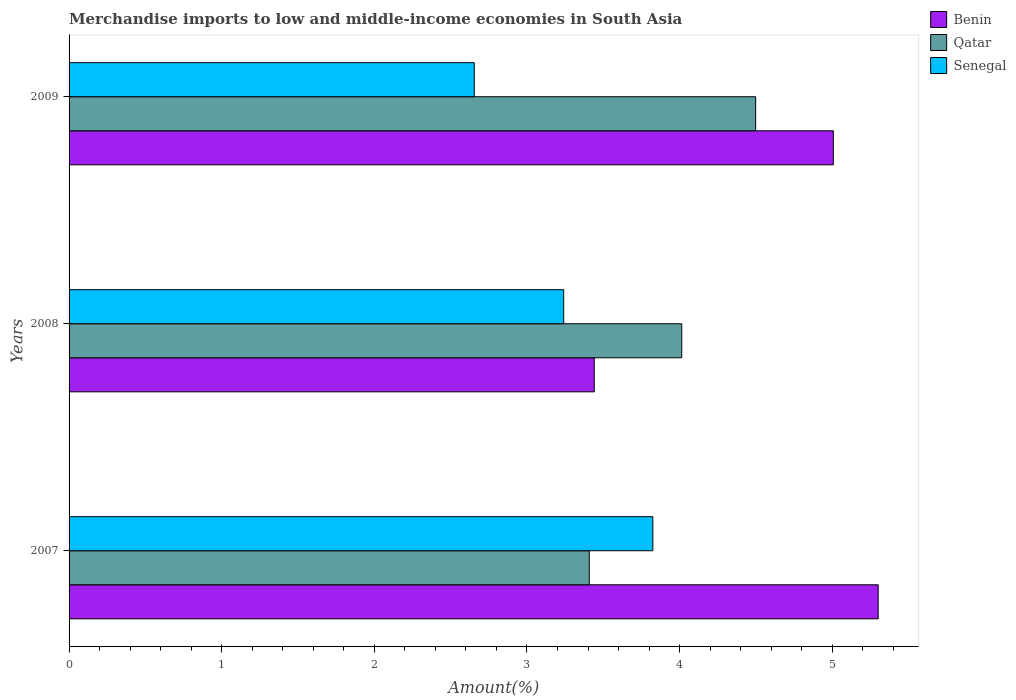Are the number of bars on each tick of the Y-axis equal?
Your answer should be very brief. Yes. How many bars are there on the 1st tick from the bottom?
Keep it short and to the point. 3. What is the label of the 2nd group of bars from the top?
Your response must be concise. 2008. What is the percentage of amount earned from merchandise imports in Senegal in 2007?
Keep it short and to the point. 3.82. Across all years, what is the maximum percentage of amount earned from merchandise imports in Qatar?
Your answer should be compact. 4.5. Across all years, what is the minimum percentage of amount earned from merchandise imports in Benin?
Make the answer very short. 3.44. In which year was the percentage of amount earned from merchandise imports in Benin maximum?
Give a very brief answer. 2007. In which year was the percentage of amount earned from merchandise imports in Benin minimum?
Your response must be concise. 2008. What is the total percentage of amount earned from merchandise imports in Qatar in the graph?
Provide a succinct answer. 11.92. What is the difference between the percentage of amount earned from merchandise imports in Senegal in 2007 and that in 2009?
Offer a terse response. 1.17. What is the difference between the percentage of amount earned from merchandise imports in Benin in 2009 and the percentage of amount earned from merchandise imports in Qatar in 2007?
Your answer should be very brief. 1.6. What is the average percentage of amount earned from merchandise imports in Qatar per year?
Keep it short and to the point. 3.97. In the year 2009, what is the difference between the percentage of amount earned from merchandise imports in Benin and percentage of amount earned from merchandise imports in Qatar?
Offer a very short reply. 0.51. What is the ratio of the percentage of amount earned from merchandise imports in Benin in 2007 to that in 2009?
Your response must be concise. 1.06. Is the difference between the percentage of amount earned from merchandise imports in Benin in 2007 and 2008 greater than the difference between the percentage of amount earned from merchandise imports in Qatar in 2007 and 2008?
Make the answer very short. Yes. What is the difference between the highest and the second highest percentage of amount earned from merchandise imports in Benin?
Provide a short and direct response. 0.29. What is the difference between the highest and the lowest percentage of amount earned from merchandise imports in Qatar?
Provide a succinct answer. 1.09. In how many years, is the percentage of amount earned from merchandise imports in Benin greater than the average percentage of amount earned from merchandise imports in Benin taken over all years?
Ensure brevity in your answer.  2. What does the 1st bar from the top in 2007 represents?
Your response must be concise. Senegal. What does the 3rd bar from the bottom in 2009 represents?
Make the answer very short. Senegal. How many years are there in the graph?
Provide a short and direct response. 3. Does the graph contain any zero values?
Your answer should be very brief. No. Where does the legend appear in the graph?
Your answer should be very brief. Top right. How many legend labels are there?
Make the answer very short. 3. How are the legend labels stacked?
Offer a terse response. Vertical. What is the title of the graph?
Ensure brevity in your answer.  Merchandise imports to low and middle-income economies in South Asia. What is the label or title of the X-axis?
Offer a terse response. Amount(%). What is the label or title of the Y-axis?
Ensure brevity in your answer.  Years. What is the Amount(%) of Benin in 2007?
Offer a very short reply. 5.3. What is the Amount(%) in Qatar in 2007?
Give a very brief answer. 3.41. What is the Amount(%) of Senegal in 2007?
Your response must be concise. 3.82. What is the Amount(%) of Benin in 2008?
Ensure brevity in your answer.  3.44. What is the Amount(%) of Qatar in 2008?
Ensure brevity in your answer.  4.01. What is the Amount(%) of Senegal in 2008?
Your answer should be very brief. 3.24. What is the Amount(%) in Benin in 2009?
Provide a succinct answer. 5.01. What is the Amount(%) of Qatar in 2009?
Provide a succinct answer. 4.5. What is the Amount(%) in Senegal in 2009?
Your answer should be compact. 2.65. Across all years, what is the maximum Amount(%) in Benin?
Give a very brief answer. 5.3. Across all years, what is the maximum Amount(%) in Qatar?
Offer a terse response. 4.5. Across all years, what is the maximum Amount(%) in Senegal?
Provide a succinct answer. 3.82. Across all years, what is the minimum Amount(%) in Benin?
Offer a terse response. 3.44. Across all years, what is the minimum Amount(%) in Qatar?
Offer a very short reply. 3.41. Across all years, what is the minimum Amount(%) in Senegal?
Your response must be concise. 2.65. What is the total Amount(%) in Benin in the graph?
Keep it short and to the point. 13.75. What is the total Amount(%) in Qatar in the graph?
Keep it short and to the point. 11.92. What is the total Amount(%) in Senegal in the graph?
Your answer should be very brief. 9.72. What is the difference between the Amount(%) in Benin in 2007 and that in 2008?
Offer a very short reply. 1.86. What is the difference between the Amount(%) of Qatar in 2007 and that in 2008?
Offer a terse response. -0.61. What is the difference between the Amount(%) of Senegal in 2007 and that in 2008?
Your answer should be very brief. 0.58. What is the difference between the Amount(%) in Benin in 2007 and that in 2009?
Keep it short and to the point. 0.29. What is the difference between the Amount(%) in Qatar in 2007 and that in 2009?
Provide a succinct answer. -1.09. What is the difference between the Amount(%) of Senegal in 2007 and that in 2009?
Keep it short and to the point. 1.17. What is the difference between the Amount(%) in Benin in 2008 and that in 2009?
Ensure brevity in your answer.  -1.57. What is the difference between the Amount(%) of Qatar in 2008 and that in 2009?
Offer a terse response. -0.48. What is the difference between the Amount(%) in Senegal in 2008 and that in 2009?
Your response must be concise. 0.59. What is the difference between the Amount(%) in Benin in 2007 and the Amount(%) in Qatar in 2008?
Keep it short and to the point. 1.29. What is the difference between the Amount(%) of Benin in 2007 and the Amount(%) of Senegal in 2008?
Your response must be concise. 2.06. What is the difference between the Amount(%) of Qatar in 2007 and the Amount(%) of Senegal in 2008?
Ensure brevity in your answer.  0.17. What is the difference between the Amount(%) in Benin in 2007 and the Amount(%) in Qatar in 2009?
Make the answer very short. 0.8. What is the difference between the Amount(%) of Benin in 2007 and the Amount(%) of Senegal in 2009?
Provide a succinct answer. 2.65. What is the difference between the Amount(%) in Qatar in 2007 and the Amount(%) in Senegal in 2009?
Offer a terse response. 0.75. What is the difference between the Amount(%) of Benin in 2008 and the Amount(%) of Qatar in 2009?
Your response must be concise. -1.06. What is the difference between the Amount(%) in Benin in 2008 and the Amount(%) in Senegal in 2009?
Your response must be concise. 0.79. What is the difference between the Amount(%) in Qatar in 2008 and the Amount(%) in Senegal in 2009?
Provide a succinct answer. 1.36. What is the average Amount(%) of Benin per year?
Offer a terse response. 4.58. What is the average Amount(%) in Qatar per year?
Keep it short and to the point. 3.97. What is the average Amount(%) of Senegal per year?
Your answer should be very brief. 3.24. In the year 2007, what is the difference between the Amount(%) of Benin and Amount(%) of Qatar?
Your response must be concise. 1.89. In the year 2007, what is the difference between the Amount(%) in Benin and Amount(%) in Senegal?
Your answer should be very brief. 1.48. In the year 2007, what is the difference between the Amount(%) in Qatar and Amount(%) in Senegal?
Keep it short and to the point. -0.42. In the year 2008, what is the difference between the Amount(%) of Benin and Amount(%) of Qatar?
Give a very brief answer. -0.57. In the year 2008, what is the difference between the Amount(%) of Benin and Amount(%) of Senegal?
Provide a succinct answer. 0.2. In the year 2008, what is the difference between the Amount(%) of Qatar and Amount(%) of Senegal?
Keep it short and to the point. 0.77. In the year 2009, what is the difference between the Amount(%) of Benin and Amount(%) of Qatar?
Offer a terse response. 0.51. In the year 2009, what is the difference between the Amount(%) in Benin and Amount(%) in Senegal?
Make the answer very short. 2.35. In the year 2009, what is the difference between the Amount(%) of Qatar and Amount(%) of Senegal?
Offer a terse response. 1.84. What is the ratio of the Amount(%) of Benin in 2007 to that in 2008?
Ensure brevity in your answer.  1.54. What is the ratio of the Amount(%) in Qatar in 2007 to that in 2008?
Ensure brevity in your answer.  0.85. What is the ratio of the Amount(%) in Senegal in 2007 to that in 2008?
Your response must be concise. 1.18. What is the ratio of the Amount(%) in Benin in 2007 to that in 2009?
Offer a very short reply. 1.06. What is the ratio of the Amount(%) in Qatar in 2007 to that in 2009?
Your response must be concise. 0.76. What is the ratio of the Amount(%) in Senegal in 2007 to that in 2009?
Offer a terse response. 1.44. What is the ratio of the Amount(%) in Benin in 2008 to that in 2009?
Make the answer very short. 0.69. What is the ratio of the Amount(%) of Qatar in 2008 to that in 2009?
Keep it short and to the point. 0.89. What is the ratio of the Amount(%) in Senegal in 2008 to that in 2009?
Offer a very short reply. 1.22. What is the difference between the highest and the second highest Amount(%) in Benin?
Make the answer very short. 0.29. What is the difference between the highest and the second highest Amount(%) of Qatar?
Ensure brevity in your answer.  0.48. What is the difference between the highest and the second highest Amount(%) of Senegal?
Offer a very short reply. 0.58. What is the difference between the highest and the lowest Amount(%) in Benin?
Give a very brief answer. 1.86. What is the difference between the highest and the lowest Amount(%) of Qatar?
Give a very brief answer. 1.09. What is the difference between the highest and the lowest Amount(%) in Senegal?
Make the answer very short. 1.17. 